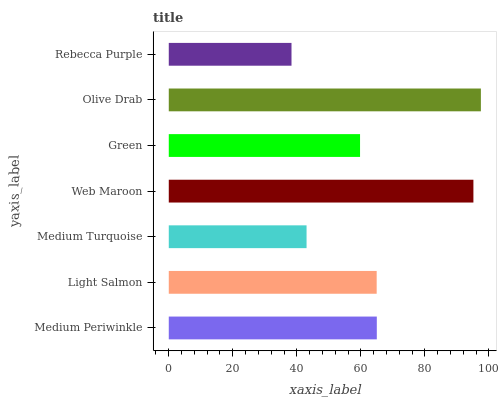Is Rebecca Purple the minimum?
Answer yes or no. Yes. Is Olive Drab the maximum?
Answer yes or no. Yes. Is Light Salmon the minimum?
Answer yes or no. No. Is Light Salmon the maximum?
Answer yes or no. No. Is Medium Periwinkle greater than Light Salmon?
Answer yes or no. Yes. Is Light Salmon less than Medium Periwinkle?
Answer yes or no. Yes. Is Light Salmon greater than Medium Periwinkle?
Answer yes or no. No. Is Medium Periwinkle less than Light Salmon?
Answer yes or no. No. Is Light Salmon the high median?
Answer yes or no. Yes. Is Light Salmon the low median?
Answer yes or no. Yes. Is Olive Drab the high median?
Answer yes or no. No. Is Olive Drab the low median?
Answer yes or no. No. 